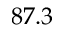Convert formula to latex. <formula><loc_0><loc_0><loc_500><loc_500>8 7 . 3</formula> 